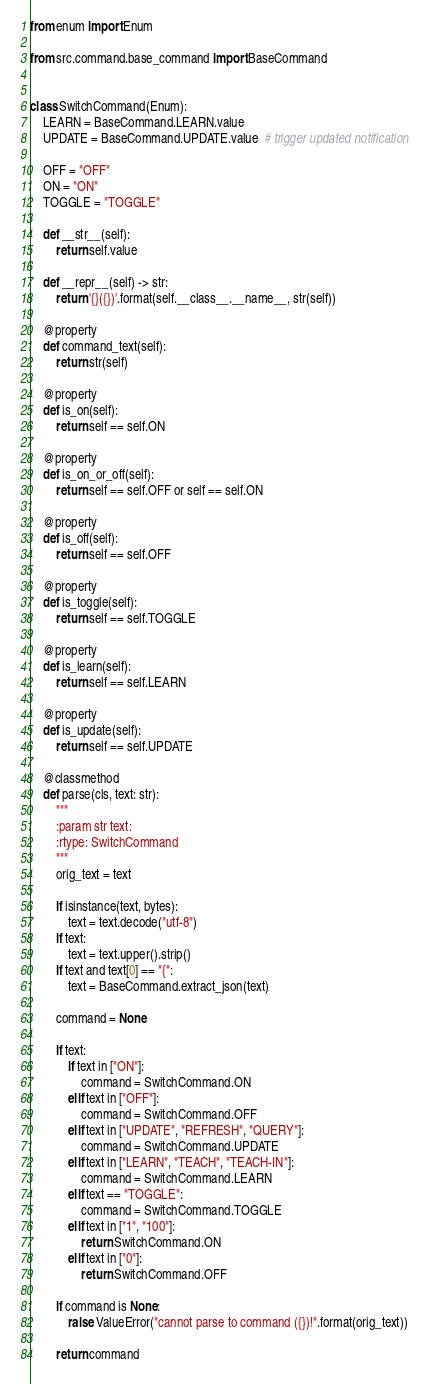Convert code to text. <code><loc_0><loc_0><loc_500><loc_500><_Python_>from enum import Enum

from src.command.base_command import BaseCommand


class SwitchCommand(Enum):
    LEARN = BaseCommand.LEARN.value
    UPDATE = BaseCommand.UPDATE.value  # trigger updated notification

    OFF = "OFF"
    ON = "ON"
    TOGGLE = "TOGGLE"

    def __str__(self):
        return self.value

    def __repr__(self) -> str:
        return '{}({})'.format(self.__class__.__name__, str(self))

    @property
    def command_text(self):
        return str(self)

    @property
    def is_on(self):
        return self == self.ON

    @property
    def is_on_or_off(self):
        return self == self.OFF or self == self.ON

    @property
    def is_off(self):
        return self == self.OFF

    @property
    def is_toggle(self):
        return self == self.TOGGLE

    @property
    def is_learn(self):
        return self == self.LEARN

    @property
    def is_update(self):
        return self == self.UPDATE

    @classmethod
    def parse(cls, text: str):
        """
        :param str text:
        :rtype: SwitchCommand
        """
        orig_text = text

        if isinstance(text, bytes):
            text = text.decode("utf-8")
        if text:
            text = text.upper().strip()
        if text and text[0] == "{":
            text = BaseCommand.extract_json(text)

        command = None

        if text:
            if text in ["ON"]:
                command = SwitchCommand.ON
            elif text in ["OFF"]:
                command = SwitchCommand.OFF
            elif text in ["UPDATE", "REFRESH", "QUERY"]:
                command = SwitchCommand.UPDATE
            elif text in ["LEARN", "TEACH", "TEACH-IN"]:
                command = SwitchCommand.LEARN
            elif text == "TOGGLE":
                command = SwitchCommand.TOGGLE
            elif text in ["1", "100"]:
                return SwitchCommand.ON
            elif text in ["0"]:
                return SwitchCommand.OFF

        if command is None:
            raise ValueError("cannot parse to command ({})!".format(orig_text))

        return command
</code> 